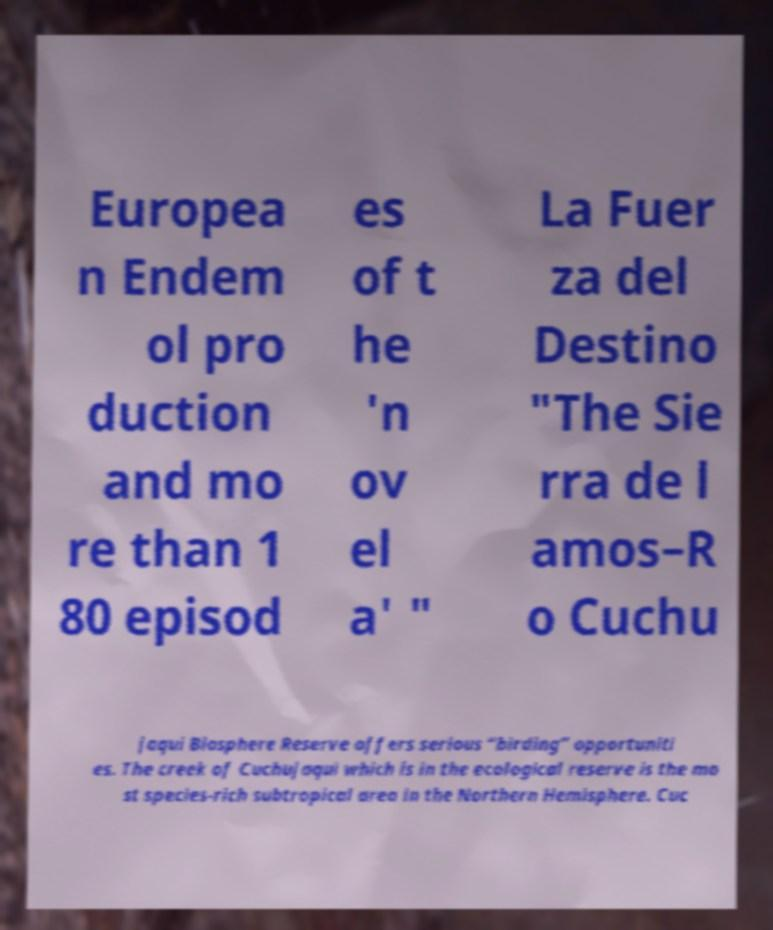For documentation purposes, I need the text within this image transcribed. Could you provide that? Europea n Endem ol pro duction and mo re than 1 80 episod es of t he 'n ov el a' " La Fuer za del Destino "The Sie rra de l amos–R o Cuchu jaqui Biosphere Reserve offers serious “birding” opportuniti es. The creek of Cuchujaqui which is in the ecological reserve is the mo st species-rich subtropical area in the Northern Hemisphere. Cuc 